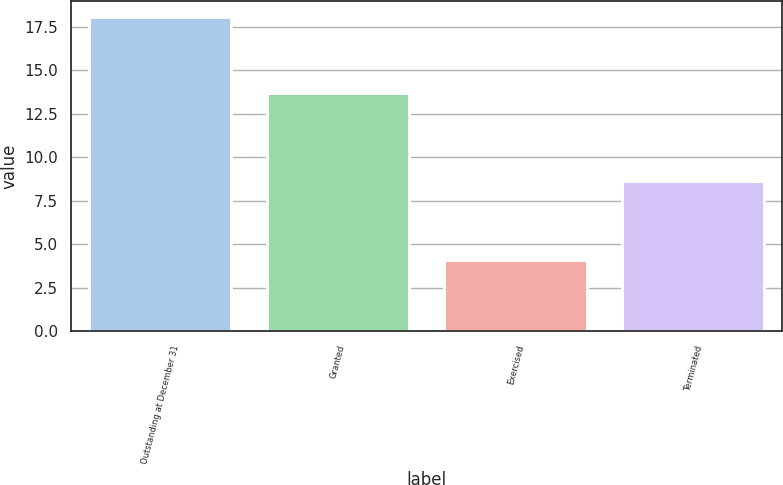Convert chart to OTSL. <chart><loc_0><loc_0><loc_500><loc_500><bar_chart><fcel>Outstanding at December 31<fcel>Granted<fcel>Exercised<fcel>Terminated<nl><fcel>18.09<fcel>13.68<fcel>4.1<fcel>8.66<nl></chart> 